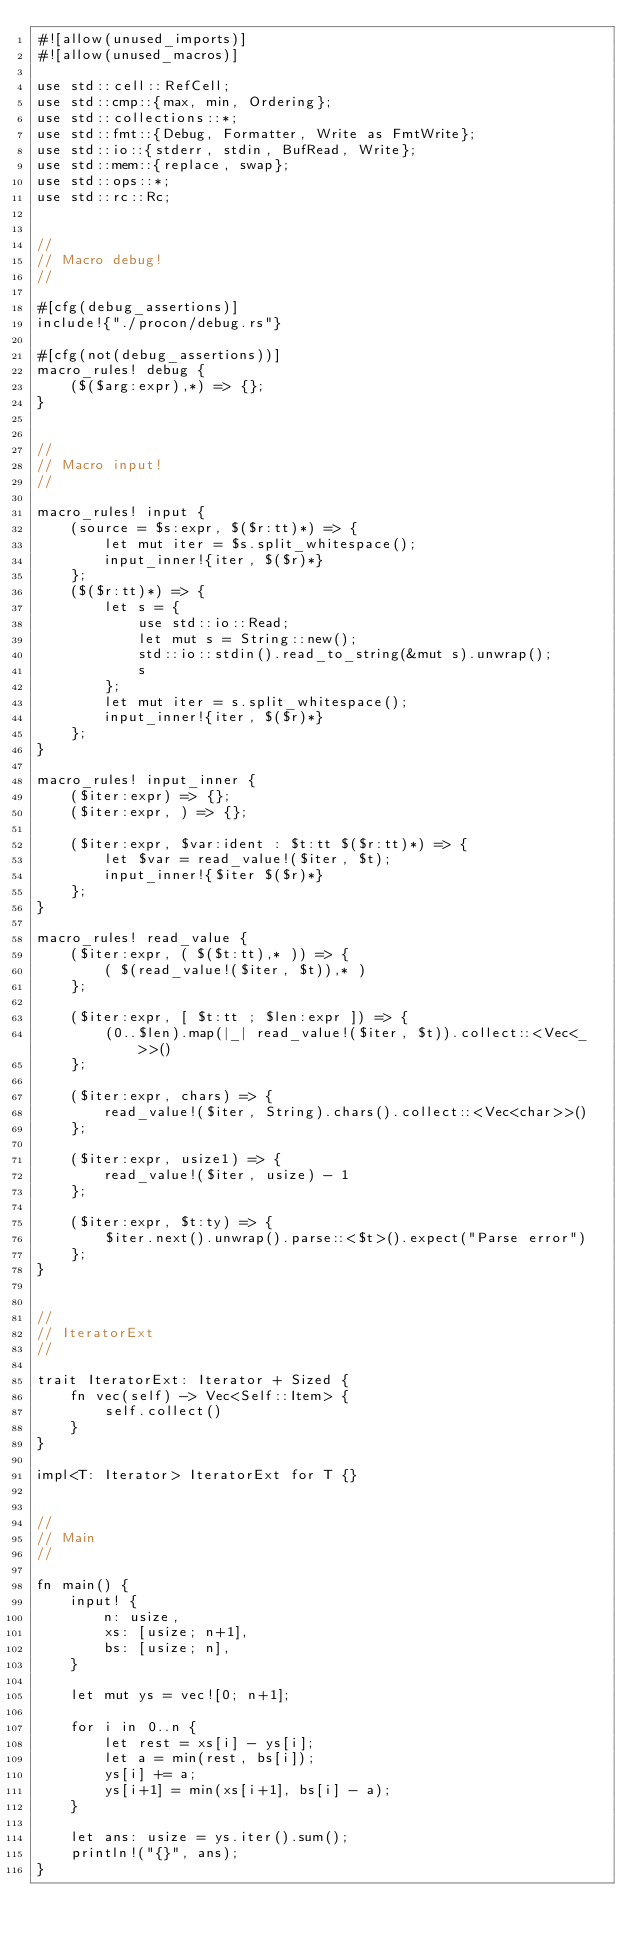<code> <loc_0><loc_0><loc_500><loc_500><_Rust_>#![allow(unused_imports)]
#![allow(unused_macros)]

use std::cell::RefCell;
use std::cmp::{max, min, Ordering};
use std::collections::*;
use std::fmt::{Debug, Formatter, Write as FmtWrite};
use std::io::{stderr, stdin, BufRead, Write};
use std::mem::{replace, swap};
use std::ops::*;
use std::rc::Rc;


//
// Macro debug!
//

#[cfg(debug_assertions)]
include!{"./procon/debug.rs"}

#[cfg(not(debug_assertions))]
macro_rules! debug {
    ($($arg:expr),*) => {};
}


//
// Macro input!
//

macro_rules! input {
    (source = $s:expr, $($r:tt)*) => {
        let mut iter = $s.split_whitespace();
        input_inner!{iter, $($r)*}
    };
    ($($r:tt)*) => {
        let s = {
            use std::io::Read;
            let mut s = String::new();
            std::io::stdin().read_to_string(&mut s).unwrap();
            s
        };
        let mut iter = s.split_whitespace();
        input_inner!{iter, $($r)*}
    };
}

macro_rules! input_inner {
    ($iter:expr) => {};
    ($iter:expr, ) => {};

    ($iter:expr, $var:ident : $t:tt $($r:tt)*) => {
        let $var = read_value!($iter, $t);
        input_inner!{$iter $($r)*}
    };
}

macro_rules! read_value {
    ($iter:expr, ( $($t:tt),* )) => {
        ( $(read_value!($iter, $t)),* )
    };

    ($iter:expr, [ $t:tt ; $len:expr ]) => {
        (0..$len).map(|_| read_value!($iter, $t)).collect::<Vec<_>>()
    };

    ($iter:expr, chars) => {
        read_value!($iter, String).chars().collect::<Vec<char>>()
    };

    ($iter:expr, usize1) => {
        read_value!($iter, usize) - 1
    };

    ($iter:expr, $t:ty) => {
        $iter.next().unwrap().parse::<$t>().expect("Parse error")
    };
}


//
// IteratorExt
//

trait IteratorExt: Iterator + Sized {
    fn vec(self) -> Vec<Self::Item> {
        self.collect()
    }
}

impl<T: Iterator> IteratorExt for T {}


//
// Main
//

fn main() {
    input! {
        n: usize,
        xs: [usize; n+1],
        bs: [usize; n],
    }

    let mut ys = vec![0; n+1];

    for i in 0..n {
        let rest = xs[i] - ys[i];
        let a = min(rest, bs[i]);
        ys[i] += a;
        ys[i+1] = min(xs[i+1], bs[i] - a);
    }

    let ans: usize = ys.iter().sum();
    println!("{}", ans);
}
</code> 